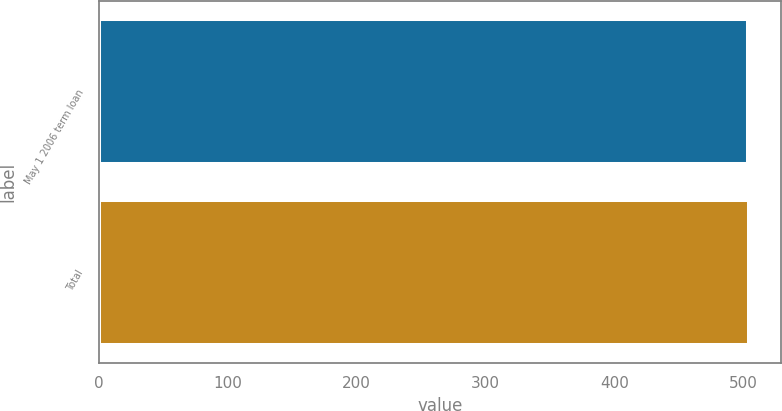Convert chart. <chart><loc_0><loc_0><loc_500><loc_500><bar_chart><fcel>May 1 2006 term loan<fcel>Total<nl><fcel>504<fcel>504.1<nl></chart> 